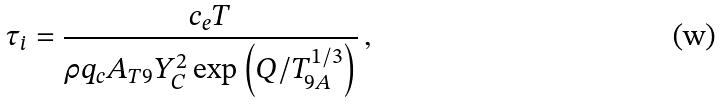Convert formula to latex. <formula><loc_0><loc_0><loc_500><loc_500>\tau _ { i } = \frac { c _ { e } T } { \rho q _ { c } A _ { T 9 } Y _ { C } ^ { 2 } \exp \left ( Q / T _ { 9 A } ^ { 1 / 3 } \right ) } \, ,</formula> 